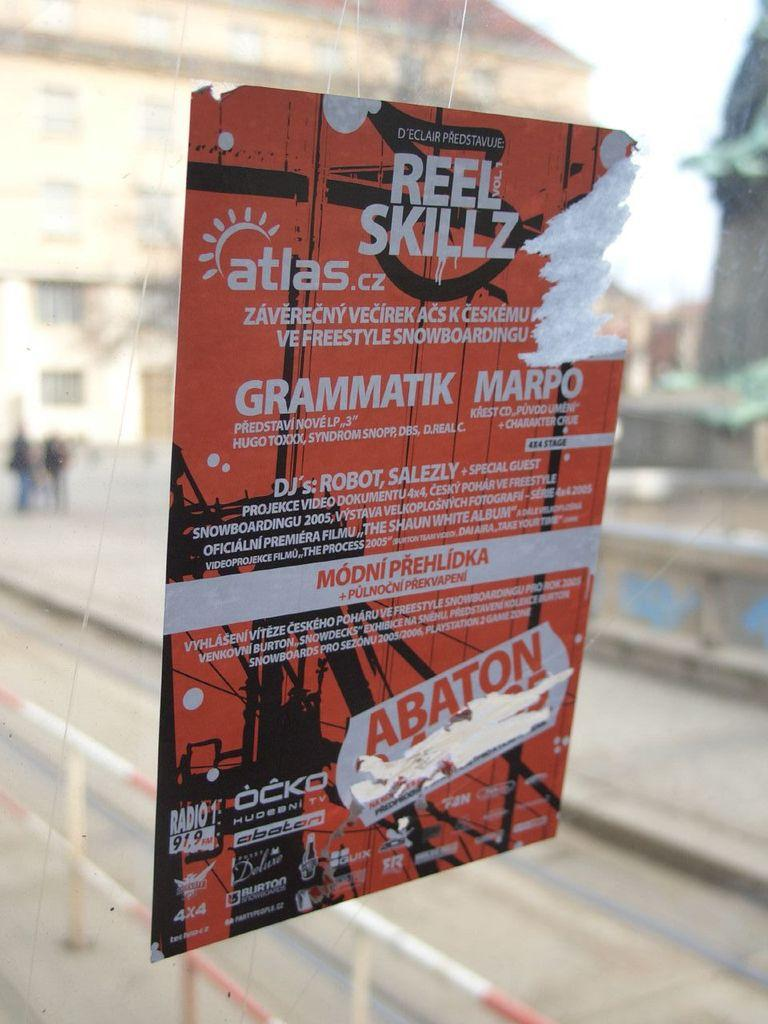<image>
Render a clear and concise summary of the photo. Window sign that is black, orange and white with Orange letters ABATON 